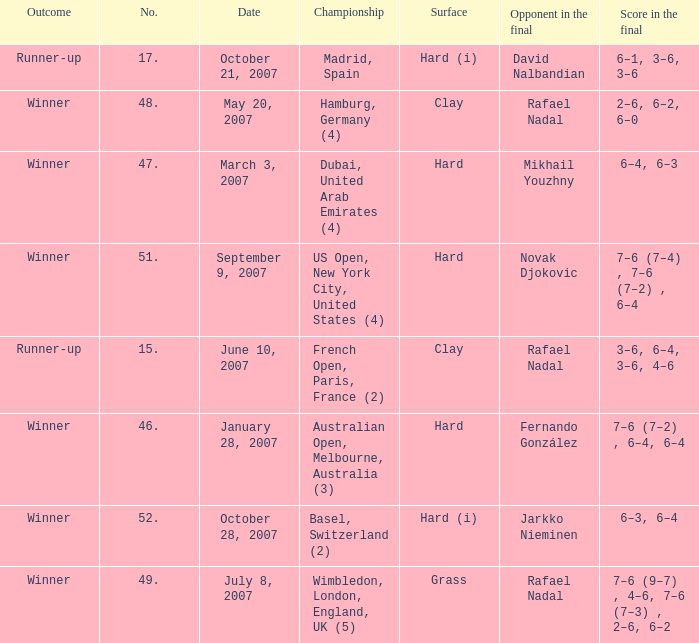Where the outcome is Winner and surface is Hard (i), what is the No.? 52.0. 